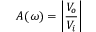<formula> <loc_0><loc_0><loc_500><loc_500>A ( \omega ) = \left | { \frac { V _ { o } } { V _ { i } } } \right |</formula> 